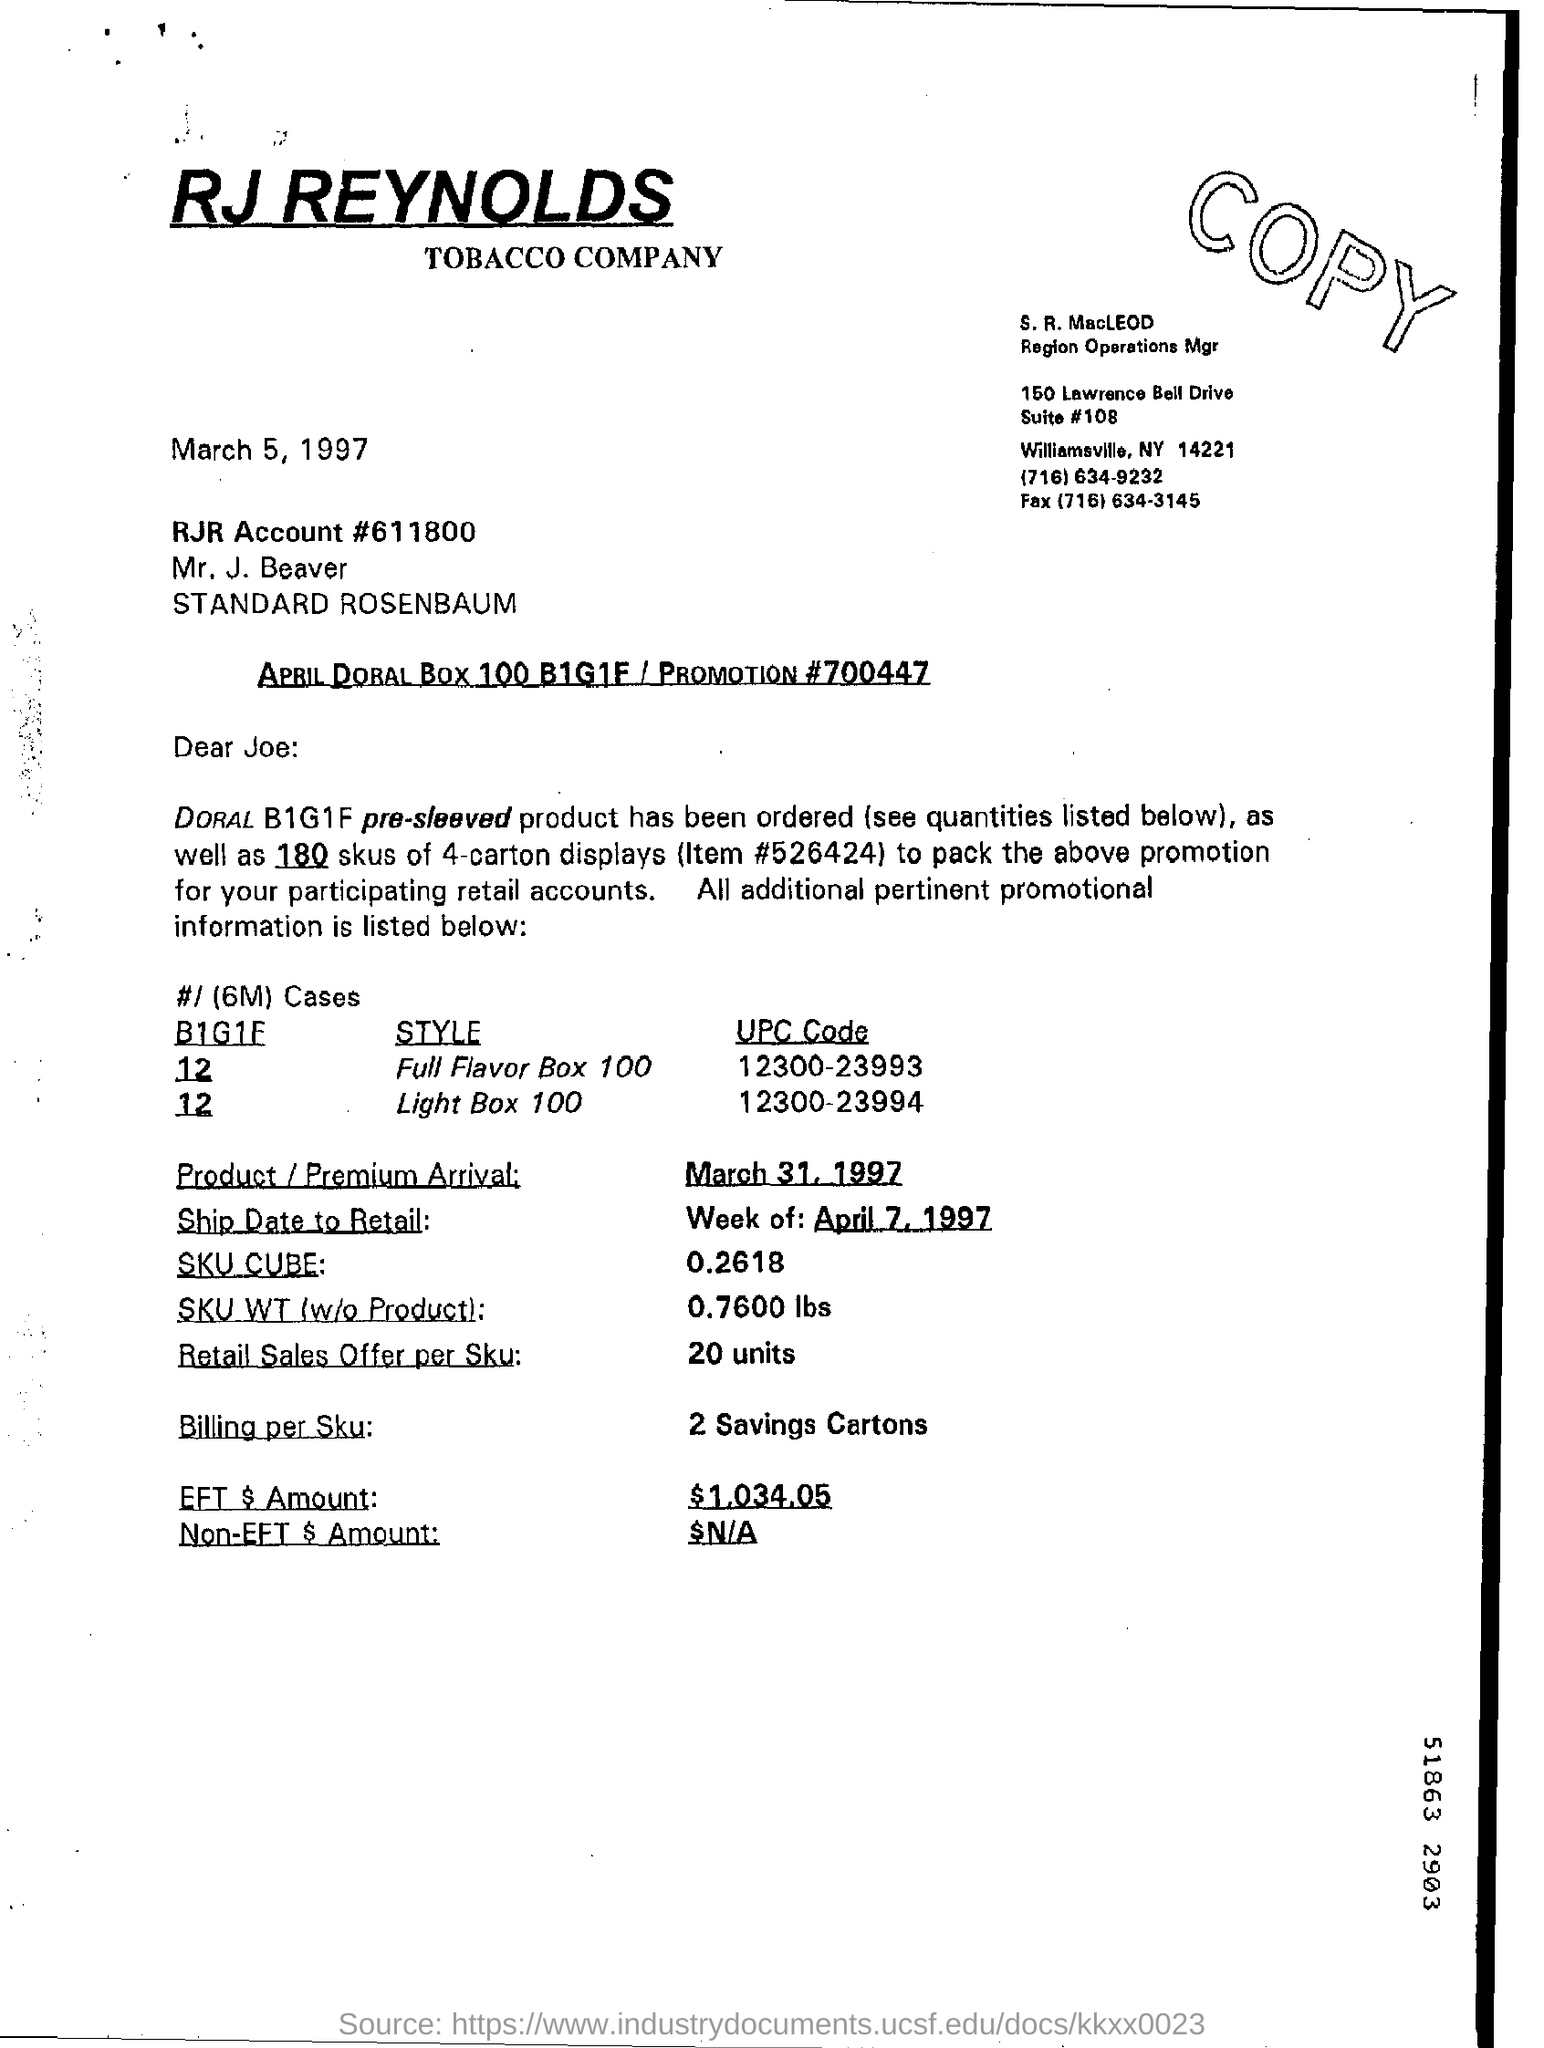Specify some key components in this picture. The UPC code for the style of full flavour box 100 is 12300-23993. The tobacco company that goes by the name RJ REYNOLDS 